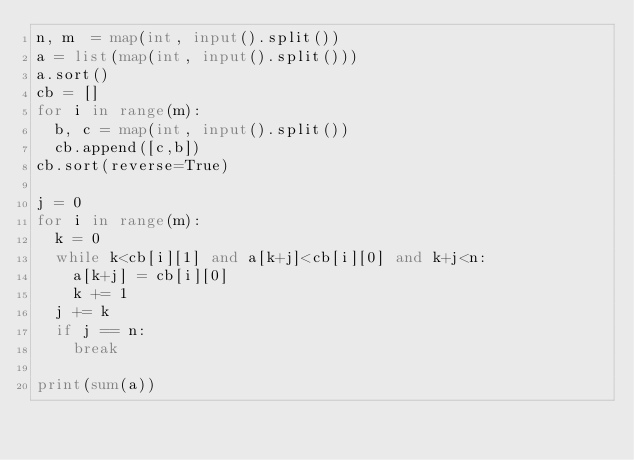<code> <loc_0><loc_0><loc_500><loc_500><_Python_>n, m  = map(int, input().split())
a = list(map(int, input().split()))
a.sort()
cb = []
for i in range(m):
  b, c = map(int, input().split())
  cb.append([c,b])
cb.sort(reverse=True)

j = 0
for i in range(m):
  k = 0
  while k<cb[i][1] and a[k+j]<cb[i][0] and k+j<n:
    a[k+j] = cb[i][0]
    k += 1
  j += k
  if j == n:
    break
    
print(sum(a))</code> 